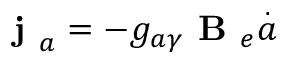Convert formula to latex. <formula><loc_0><loc_0><loc_500><loc_500>j _ { a } = - g _ { a \gamma } B _ { e } \overset { . } { a }</formula> 